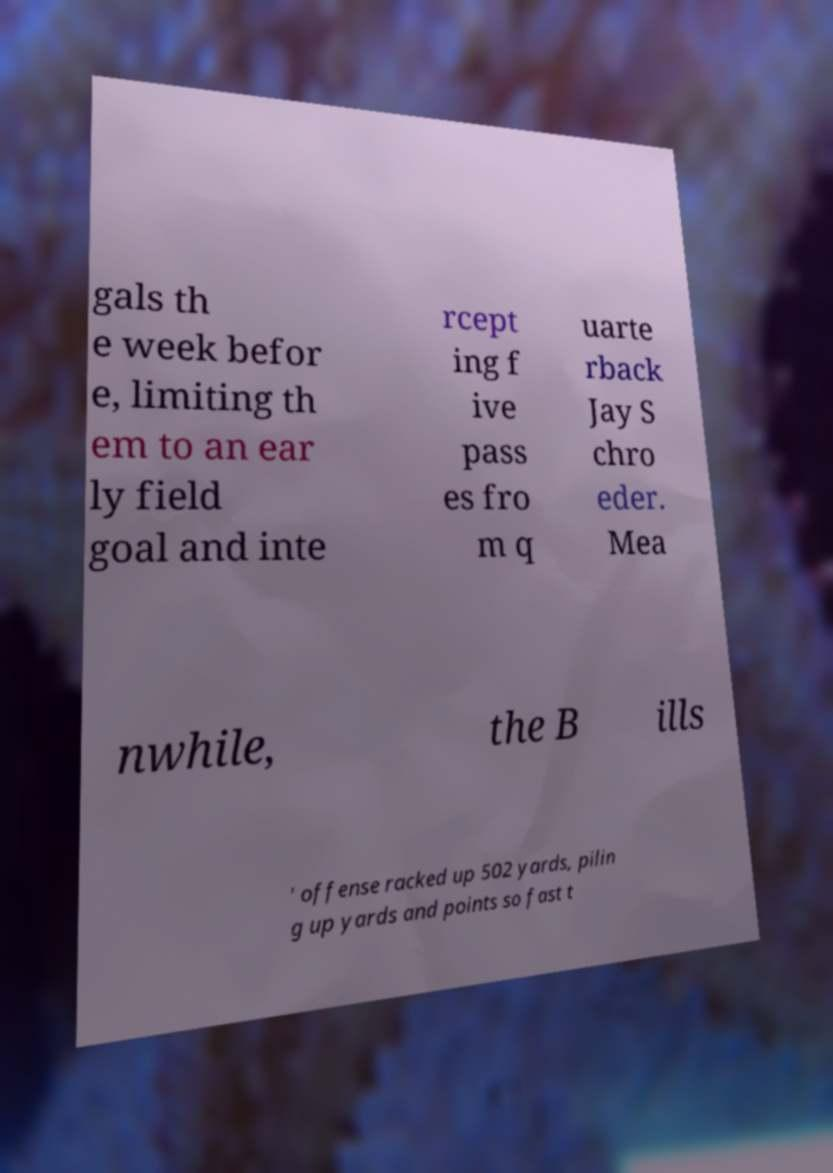Can you accurately transcribe the text from the provided image for me? gals th e week befor e, limiting th em to an ear ly field goal and inte rcept ing f ive pass es fro m q uarte rback Jay S chro eder. Mea nwhile, the B ills ' offense racked up 502 yards, pilin g up yards and points so fast t 